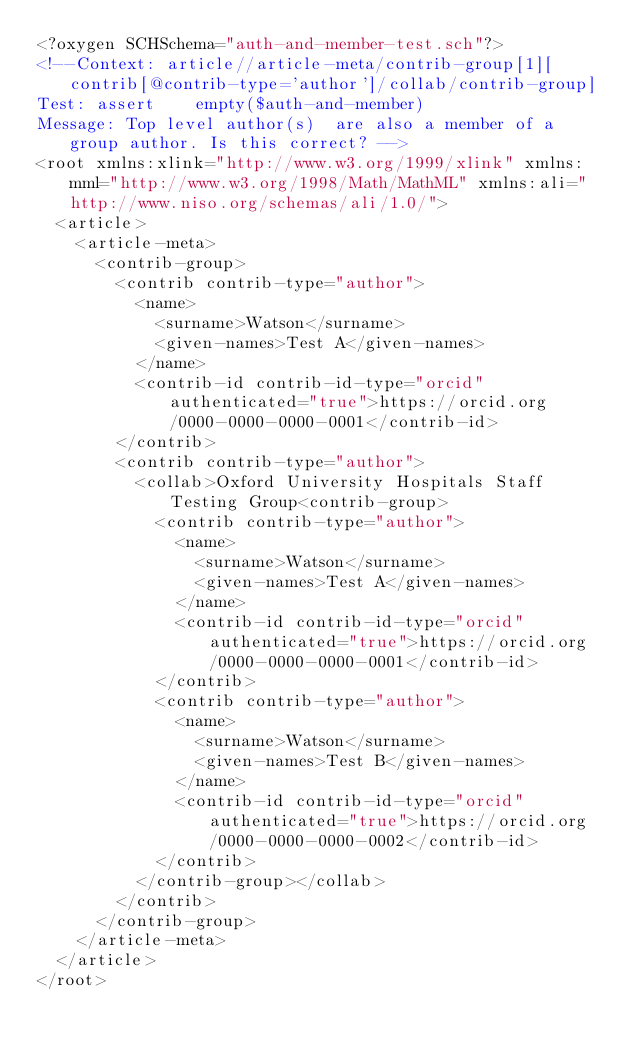Convert code to text. <code><loc_0><loc_0><loc_500><loc_500><_XML_><?oxygen SCHSchema="auth-and-member-test.sch"?>
<!--Context: article//article-meta/contrib-group[1][contrib[@contrib-type='author']/collab/contrib-group]
Test: assert    empty($auth-and-member)
Message: Top level author(s)  are also a member of a group author. Is this correct? -->
<root xmlns:xlink="http://www.w3.org/1999/xlink" xmlns:mml="http://www.w3.org/1998/Math/MathML" xmlns:ali="http://www.niso.org/schemas/ali/1.0/">
  <article>
    <article-meta>
      <contrib-group>
        <contrib contrib-type="author">
          <name>
            <surname>Watson</surname>
            <given-names>Test A</given-names>
          </name>
          <contrib-id contrib-id-type="orcid" authenticated="true">https://orcid.org/0000-0000-0000-0001</contrib-id>
        </contrib>
        <contrib contrib-type="author">
          <collab>Oxford University Hospitals Staff Testing Group<contrib-group>
            <contrib contrib-type="author">
              <name>
                <surname>Watson</surname>
                <given-names>Test A</given-names>
              </name>
              <contrib-id contrib-id-type="orcid" authenticated="true">https://orcid.org/0000-0000-0000-0001</contrib-id>
            </contrib>
            <contrib contrib-type="author">
              <name>
                <surname>Watson</surname>
                <given-names>Test B</given-names>
              </name>
              <contrib-id contrib-id-type="orcid" authenticated="true">https://orcid.org/0000-0000-0000-0002</contrib-id>
            </contrib>
          </contrib-group></collab>
        </contrib>
      </contrib-group>
    </article-meta>
  </article>
</root></code> 